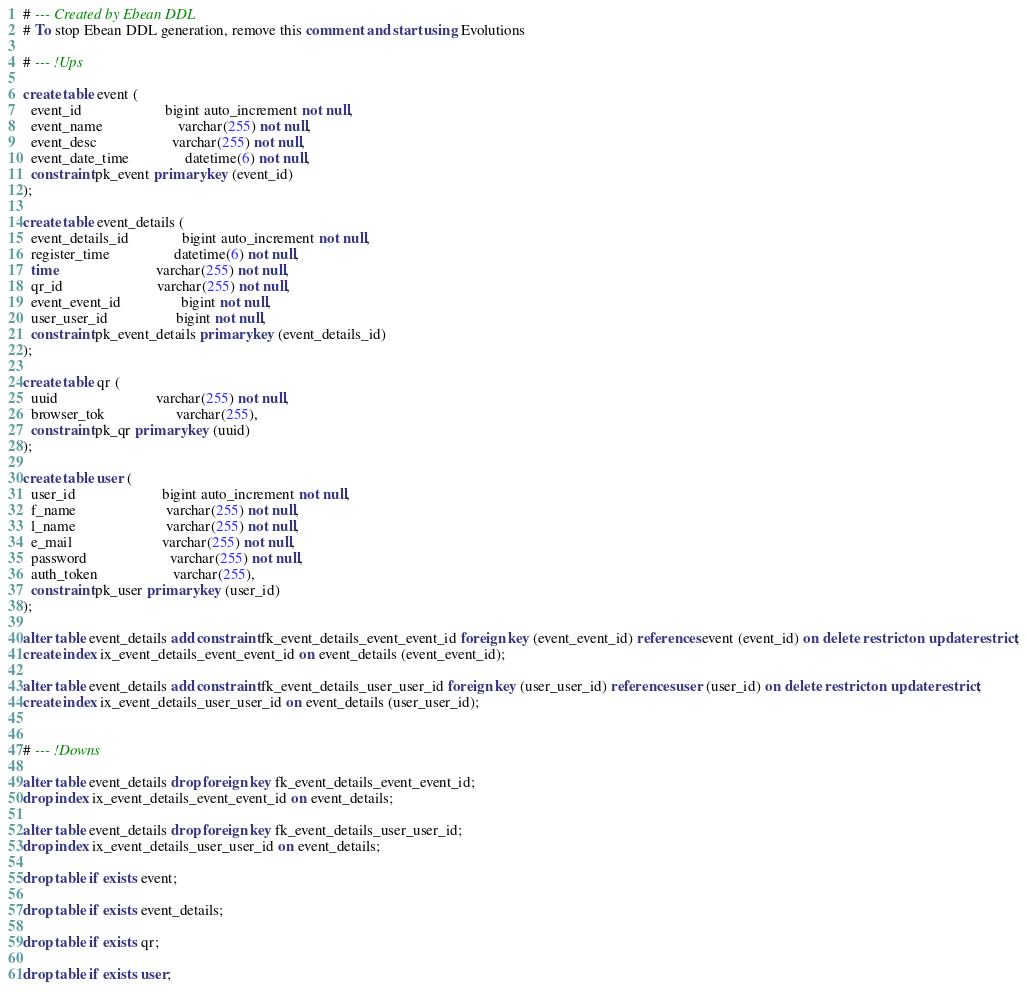Convert code to text. <code><loc_0><loc_0><loc_500><loc_500><_SQL_># --- Created by Ebean DDL
# To stop Ebean DDL generation, remove this comment and start using Evolutions

# --- !Ups

create table event (
  event_id                      bigint auto_increment not null,
  event_name                    varchar(255) not null,
  event_desc                    varchar(255) not null,
  event_date_time               datetime(6) not null,
  constraint pk_event primary key (event_id)
);

create table event_details (
  event_details_id              bigint auto_increment not null,
  register_time                 datetime(6) not null,
  time                          varchar(255) not null,
  qr_id                         varchar(255) not null,
  event_event_id                bigint not null,
  user_user_id                  bigint not null,
  constraint pk_event_details primary key (event_details_id)
);

create table qr (
  uuid                          varchar(255) not null,
  browser_tok                   varchar(255),
  constraint pk_qr primary key (uuid)
);

create table user (
  user_id                       bigint auto_increment not null,
  f_name                        varchar(255) not null,
  l_name                        varchar(255) not null,
  e_mail                        varchar(255) not null,
  password                      varchar(255) not null,
  auth_token                    varchar(255),
  constraint pk_user primary key (user_id)
);

alter table event_details add constraint fk_event_details_event_event_id foreign key (event_event_id) references event (event_id) on delete restrict on update restrict;
create index ix_event_details_event_event_id on event_details (event_event_id);

alter table event_details add constraint fk_event_details_user_user_id foreign key (user_user_id) references user (user_id) on delete restrict on update restrict;
create index ix_event_details_user_user_id on event_details (user_user_id);


# --- !Downs

alter table event_details drop foreign key fk_event_details_event_event_id;
drop index ix_event_details_event_event_id on event_details;

alter table event_details drop foreign key fk_event_details_user_user_id;
drop index ix_event_details_user_user_id on event_details;

drop table if exists event;

drop table if exists event_details;

drop table if exists qr;

drop table if exists user;

</code> 